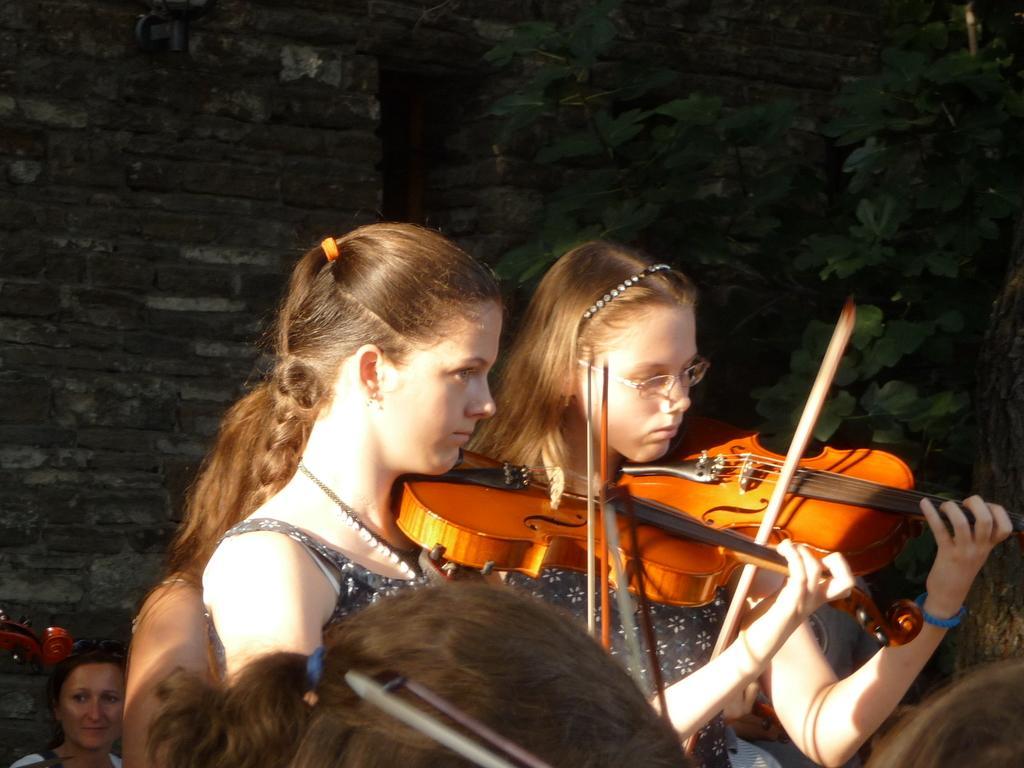Describe this image in one or two sentences. In this picture there are two women playing violin. In the background there is a wall and a plant. 